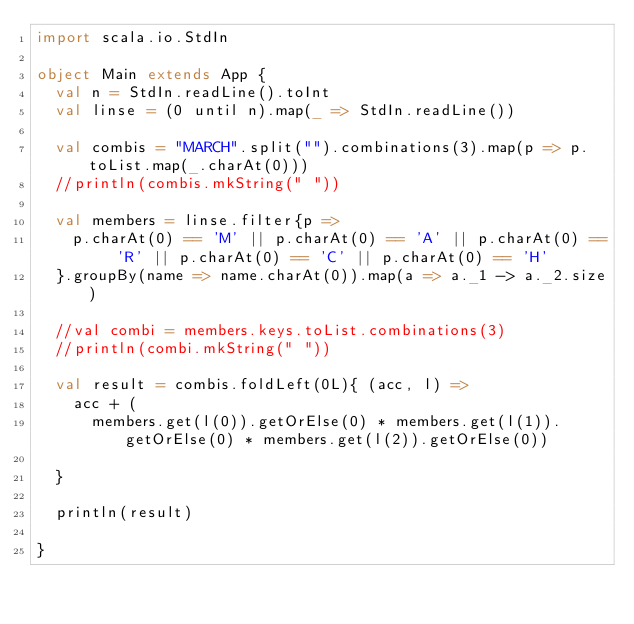Convert code to text. <code><loc_0><loc_0><loc_500><loc_500><_Scala_>import scala.io.StdIn

object Main extends App {
  val n = StdIn.readLine().toInt
  val linse = (0 until n).map(_ => StdIn.readLine())
  
  val combis = "MARCH".split("").combinations(3).map(p => p.toList.map(_.charAt(0)))
  //println(combis.mkString(" "))
  
  val members = linse.filter{p => 
    p.charAt(0) == 'M' || p.charAt(0) == 'A' || p.charAt(0) == 'R' || p.charAt(0) == 'C' || p.charAt(0) == 'H'
  }.groupBy(name => name.charAt(0)).map(a => a._1 -> a._2.size)
  
  //val combi = members.keys.toList.combinations(3)
  //println(combi.mkString(" "))
  
  val result = combis.foldLeft(0L){ (acc, l) =>
    acc + (
      members.get(l(0)).getOrElse(0) * members.get(l(1)).getOrElse(0) * members.get(l(2)).getOrElse(0))

  }

  println(result)

}
</code> 